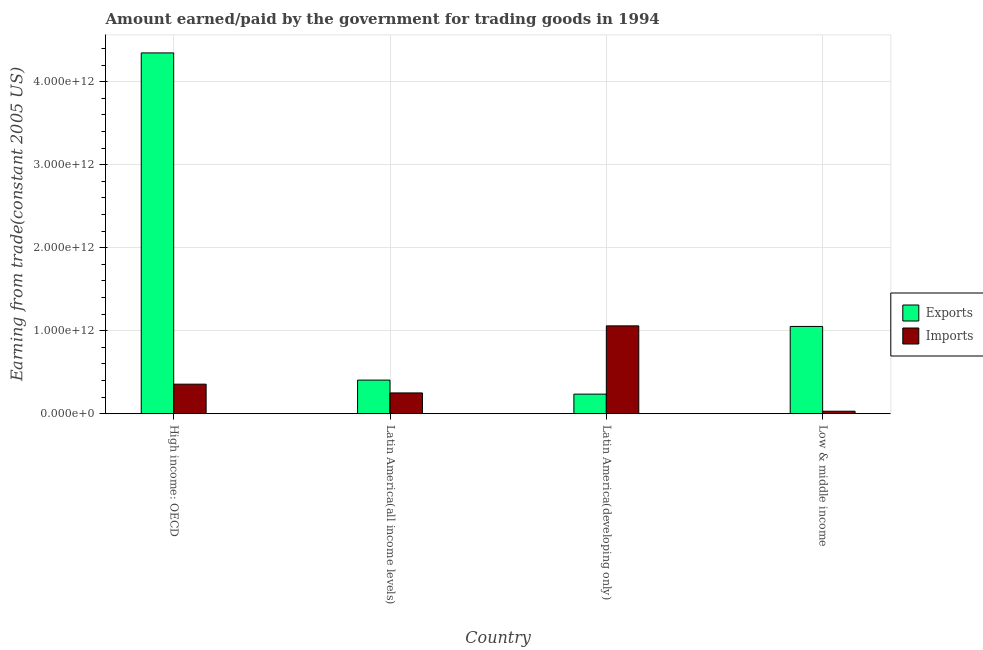How many different coloured bars are there?
Give a very brief answer. 2. How many groups of bars are there?
Offer a very short reply. 4. Are the number of bars on each tick of the X-axis equal?
Your answer should be compact. Yes. How many bars are there on the 2nd tick from the right?
Provide a succinct answer. 2. What is the label of the 3rd group of bars from the left?
Offer a terse response. Latin America(developing only). In how many cases, is the number of bars for a given country not equal to the number of legend labels?
Ensure brevity in your answer.  0. What is the amount earned from exports in Latin America(developing only)?
Keep it short and to the point. 2.36e+11. Across all countries, what is the maximum amount paid for imports?
Give a very brief answer. 1.06e+12. Across all countries, what is the minimum amount paid for imports?
Provide a short and direct response. 3.04e+1. In which country was the amount paid for imports maximum?
Offer a very short reply. Latin America(developing only). In which country was the amount paid for imports minimum?
Offer a very short reply. Low & middle income. What is the total amount paid for imports in the graph?
Offer a very short reply. 1.70e+12. What is the difference between the amount earned from exports in Latin America(all income levels) and that in Latin America(developing only)?
Offer a terse response. 1.69e+11. What is the difference between the amount paid for imports in High income: OECD and the amount earned from exports in Low & middle income?
Your response must be concise. -6.95e+11. What is the average amount paid for imports per country?
Give a very brief answer. 4.24e+11. What is the difference between the amount paid for imports and amount earned from exports in Latin America(all income levels)?
Give a very brief answer. -1.55e+11. What is the ratio of the amount earned from exports in Latin America(developing only) to that in Low & middle income?
Give a very brief answer. 0.22. Is the difference between the amount paid for imports in Latin America(all income levels) and Latin America(developing only) greater than the difference between the amount earned from exports in Latin America(all income levels) and Latin America(developing only)?
Offer a terse response. No. What is the difference between the highest and the second highest amount earned from exports?
Offer a terse response. 3.29e+12. What is the difference between the highest and the lowest amount earned from exports?
Offer a very short reply. 4.11e+12. In how many countries, is the amount earned from exports greater than the average amount earned from exports taken over all countries?
Your response must be concise. 1. What does the 1st bar from the left in Latin America(all income levels) represents?
Your answer should be very brief. Exports. What does the 2nd bar from the right in High income: OECD represents?
Your answer should be very brief. Exports. What is the difference between two consecutive major ticks on the Y-axis?
Offer a terse response. 1.00e+12. Are the values on the major ticks of Y-axis written in scientific E-notation?
Keep it short and to the point. Yes. Where does the legend appear in the graph?
Offer a very short reply. Center right. How are the legend labels stacked?
Provide a succinct answer. Vertical. What is the title of the graph?
Offer a terse response. Amount earned/paid by the government for trading goods in 1994. Does "Broad money growth" appear as one of the legend labels in the graph?
Your answer should be compact. No. What is the label or title of the X-axis?
Your answer should be very brief. Country. What is the label or title of the Y-axis?
Ensure brevity in your answer.  Earning from trade(constant 2005 US). What is the Earning from trade(constant 2005 US) in Exports in High income: OECD?
Offer a terse response. 4.35e+12. What is the Earning from trade(constant 2005 US) of Imports in High income: OECD?
Provide a succinct answer. 3.56e+11. What is the Earning from trade(constant 2005 US) in Exports in Latin America(all income levels)?
Your response must be concise. 4.05e+11. What is the Earning from trade(constant 2005 US) in Imports in Latin America(all income levels)?
Make the answer very short. 2.51e+11. What is the Earning from trade(constant 2005 US) in Exports in Latin America(developing only)?
Offer a terse response. 2.36e+11. What is the Earning from trade(constant 2005 US) in Imports in Latin America(developing only)?
Offer a terse response. 1.06e+12. What is the Earning from trade(constant 2005 US) of Exports in Low & middle income?
Make the answer very short. 1.05e+12. What is the Earning from trade(constant 2005 US) of Imports in Low & middle income?
Provide a succinct answer. 3.04e+1. Across all countries, what is the maximum Earning from trade(constant 2005 US) of Exports?
Make the answer very short. 4.35e+12. Across all countries, what is the maximum Earning from trade(constant 2005 US) of Imports?
Your answer should be compact. 1.06e+12. Across all countries, what is the minimum Earning from trade(constant 2005 US) of Exports?
Ensure brevity in your answer.  2.36e+11. Across all countries, what is the minimum Earning from trade(constant 2005 US) of Imports?
Your answer should be very brief. 3.04e+1. What is the total Earning from trade(constant 2005 US) in Exports in the graph?
Your answer should be very brief. 6.04e+12. What is the total Earning from trade(constant 2005 US) in Imports in the graph?
Offer a very short reply. 1.70e+12. What is the difference between the Earning from trade(constant 2005 US) in Exports in High income: OECD and that in Latin America(all income levels)?
Keep it short and to the point. 3.94e+12. What is the difference between the Earning from trade(constant 2005 US) in Imports in High income: OECD and that in Latin America(all income levels)?
Provide a succinct answer. 1.06e+11. What is the difference between the Earning from trade(constant 2005 US) in Exports in High income: OECD and that in Latin America(developing only)?
Provide a short and direct response. 4.11e+12. What is the difference between the Earning from trade(constant 2005 US) of Imports in High income: OECD and that in Latin America(developing only)?
Ensure brevity in your answer.  -7.02e+11. What is the difference between the Earning from trade(constant 2005 US) of Exports in High income: OECD and that in Low & middle income?
Your answer should be compact. 3.29e+12. What is the difference between the Earning from trade(constant 2005 US) in Imports in High income: OECD and that in Low & middle income?
Ensure brevity in your answer.  3.26e+11. What is the difference between the Earning from trade(constant 2005 US) in Exports in Latin America(all income levels) and that in Latin America(developing only)?
Keep it short and to the point. 1.69e+11. What is the difference between the Earning from trade(constant 2005 US) of Imports in Latin America(all income levels) and that in Latin America(developing only)?
Provide a short and direct response. -8.08e+11. What is the difference between the Earning from trade(constant 2005 US) of Exports in Latin America(all income levels) and that in Low & middle income?
Provide a short and direct response. -6.46e+11. What is the difference between the Earning from trade(constant 2005 US) of Imports in Latin America(all income levels) and that in Low & middle income?
Your answer should be very brief. 2.20e+11. What is the difference between the Earning from trade(constant 2005 US) of Exports in Latin America(developing only) and that in Low & middle income?
Provide a succinct answer. -8.15e+11. What is the difference between the Earning from trade(constant 2005 US) of Imports in Latin America(developing only) and that in Low & middle income?
Give a very brief answer. 1.03e+12. What is the difference between the Earning from trade(constant 2005 US) of Exports in High income: OECD and the Earning from trade(constant 2005 US) of Imports in Latin America(all income levels)?
Offer a terse response. 4.10e+12. What is the difference between the Earning from trade(constant 2005 US) in Exports in High income: OECD and the Earning from trade(constant 2005 US) in Imports in Latin America(developing only)?
Your response must be concise. 3.29e+12. What is the difference between the Earning from trade(constant 2005 US) in Exports in High income: OECD and the Earning from trade(constant 2005 US) in Imports in Low & middle income?
Ensure brevity in your answer.  4.32e+12. What is the difference between the Earning from trade(constant 2005 US) in Exports in Latin America(all income levels) and the Earning from trade(constant 2005 US) in Imports in Latin America(developing only)?
Provide a short and direct response. -6.53e+11. What is the difference between the Earning from trade(constant 2005 US) in Exports in Latin America(all income levels) and the Earning from trade(constant 2005 US) in Imports in Low & middle income?
Give a very brief answer. 3.75e+11. What is the difference between the Earning from trade(constant 2005 US) in Exports in Latin America(developing only) and the Earning from trade(constant 2005 US) in Imports in Low & middle income?
Your response must be concise. 2.06e+11. What is the average Earning from trade(constant 2005 US) in Exports per country?
Give a very brief answer. 1.51e+12. What is the average Earning from trade(constant 2005 US) in Imports per country?
Provide a short and direct response. 4.24e+11. What is the difference between the Earning from trade(constant 2005 US) of Exports and Earning from trade(constant 2005 US) of Imports in High income: OECD?
Ensure brevity in your answer.  3.99e+12. What is the difference between the Earning from trade(constant 2005 US) of Exports and Earning from trade(constant 2005 US) of Imports in Latin America(all income levels)?
Offer a very short reply. 1.55e+11. What is the difference between the Earning from trade(constant 2005 US) in Exports and Earning from trade(constant 2005 US) in Imports in Latin America(developing only)?
Provide a short and direct response. -8.22e+11. What is the difference between the Earning from trade(constant 2005 US) in Exports and Earning from trade(constant 2005 US) in Imports in Low & middle income?
Your answer should be compact. 1.02e+12. What is the ratio of the Earning from trade(constant 2005 US) in Exports in High income: OECD to that in Latin America(all income levels)?
Provide a short and direct response. 10.73. What is the ratio of the Earning from trade(constant 2005 US) in Imports in High income: OECD to that in Latin America(all income levels)?
Keep it short and to the point. 1.42. What is the ratio of the Earning from trade(constant 2005 US) in Exports in High income: OECD to that in Latin America(developing only)?
Your answer should be very brief. 18.4. What is the ratio of the Earning from trade(constant 2005 US) of Imports in High income: OECD to that in Latin America(developing only)?
Provide a succinct answer. 0.34. What is the ratio of the Earning from trade(constant 2005 US) in Exports in High income: OECD to that in Low & middle income?
Your response must be concise. 4.13. What is the ratio of the Earning from trade(constant 2005 US) in Imports in High income: OECD to that in Low & middle income?
Your answer should be very brief. 11.73. What is the ratio of the Earning from trade(constant 2005 US) in Exports in Latin America(all income levels) to that in Latin America(developing only)?
Make the answer very short. 1.72. What is the ratio of the Earning from trade(constant 2005 US) in Imports in Latin America(all income levels) to that in Latin America(developing only)?
Keep it short and to the point. 0.24. What is the ratio of the Earning from trade(constant 2005 US) in Exports in Latin America(all income levels) to that in Low & middle income?
Your answer should be compact. 0.39. What is the ratio of the Earning from trade(constant 2005 US) of Imports in Latin America(all income levels) to that in Low & middle income?
Your response must be concise. 8.25. What is the ratio of the Earning from trade(constant 2005 US) of Exports in Latin America(developing only) to that in Low & middle income?
Keep it short and to the point. 0.22. What is the ratio of the Earning from trade(constant 2005 US) in Imports in Latin America(developing only) to that in Low & middle income?
Provide a short and direct response. 34.86. What is the difference between the highest and the second highest Earning from trade(constant 2005 US) of Exports?
Offer a very short reply. 3.29e+12. What is the difference between the highest and the second highest Earning from trade(constant 2005 US) of Imports?
Offer a very short reply. 7.02e+11. What is the difference between the highest and the lowest Earning from trade(constant 2005 US) of Exports?
Your answer should be compact. 4.11e+12. What is the difference between the highest and the lowest Earning from trade(constant 2005 US) of Imports?
Offer a terse response. 1.03e+12. 